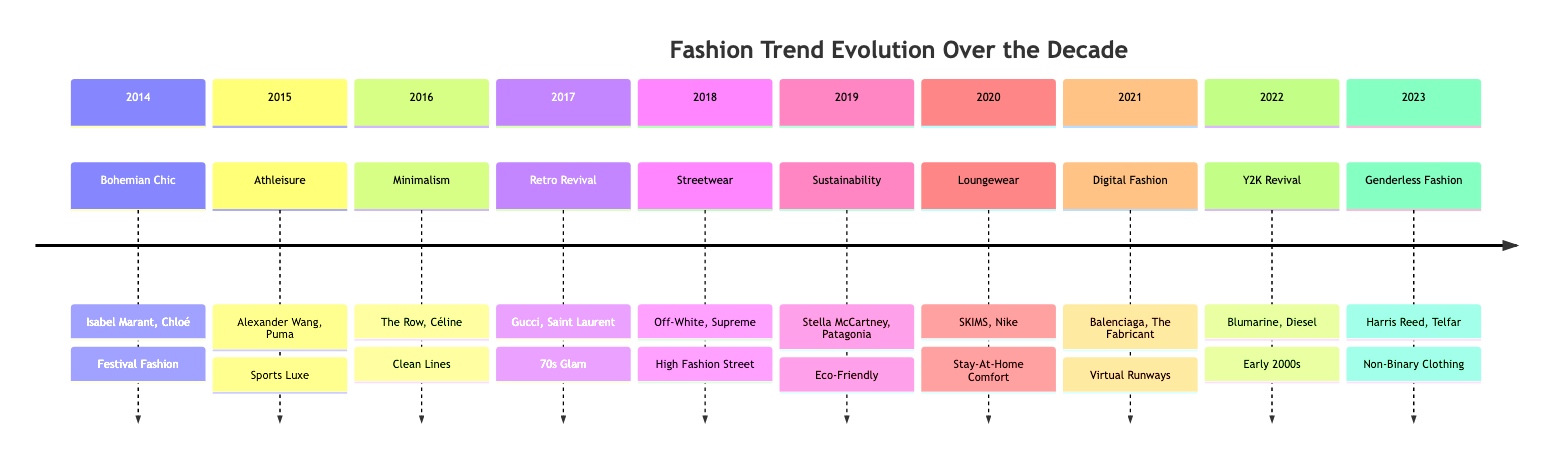What fashion style was popular in 2015? In 2015, the style labeled was "Athleisure," which was associated with designers Alexander Wang and Puma. This pair provides a clear indication that Athleisure was the focal style for that year.
Answer: Athleisure Which designers are linked to the 2018 fashion movement? The 2018 fashion movement noted in the diagram is "Streetwear," which lists Off-White and Supreme as key designers. Thus, these designers define the fashion landscape for that year.
Answer: Off-White, Supreme What is the key theme of fashion in 2019? The key theme for fashion in 2019 as displayed in the diagram is "Sustainability." This indicates that fashion trends were focused on eco-friendliness during that period.
Answer: Sustainability How many fashion movements are represented in the diagram? By inspecting the sections that show distinct fashion movements, we can count a total of ten sections covering different years from 2014 to 2023. Each section corresponds to a unique fashion movement, affirming the count.
Answer: 10 Which year saw the introduction of Genderless Fashion? Referring directly to the timeline, Genderless Fashion was specifically introduced in 2023. This is the designated year associated with this particular trend in the diagram.
Answer: 2023 What common element is found in the fashion movements from 2014 to 2020? Between 2014 and 2020, each listed movement aligns with a specific lifestyle or social theme, such as Loungewear for comfort or Sustainability focusing on eco-friendliness. This correlation illustrates a broader shift in consumer priorities.
Answer: Lifestyle or Social Theme Which two years feature the "Revival" themes? The years that include the "Revival" themes are 2017 with "Retro Revival" and 2022 with "Y2K Revival." These years exhibit a return to previous styles which is expressed through these revival themes.
Answer: 2017, 2022 What type of fashion is linked to the designers Balenciaga and The Fabricant? The designers Balenciaga and The Fabricant are associated with "Digital Fashion" in the year 2021. This connects them to a modern art form in fashion, utilizing digital platforms and virtual concepts.
Answer: Digital Fashion What does the term 'Eco-Friendly' refer to in the context of the 2019 fashion trend? The term 'Eco-Friendly' is a descriptor for the 2019 movement of "Sustainability," indicating that this trend emphasizes environmentally conscious practices and materials in fashion design.
Answer: Eco-Friendly 